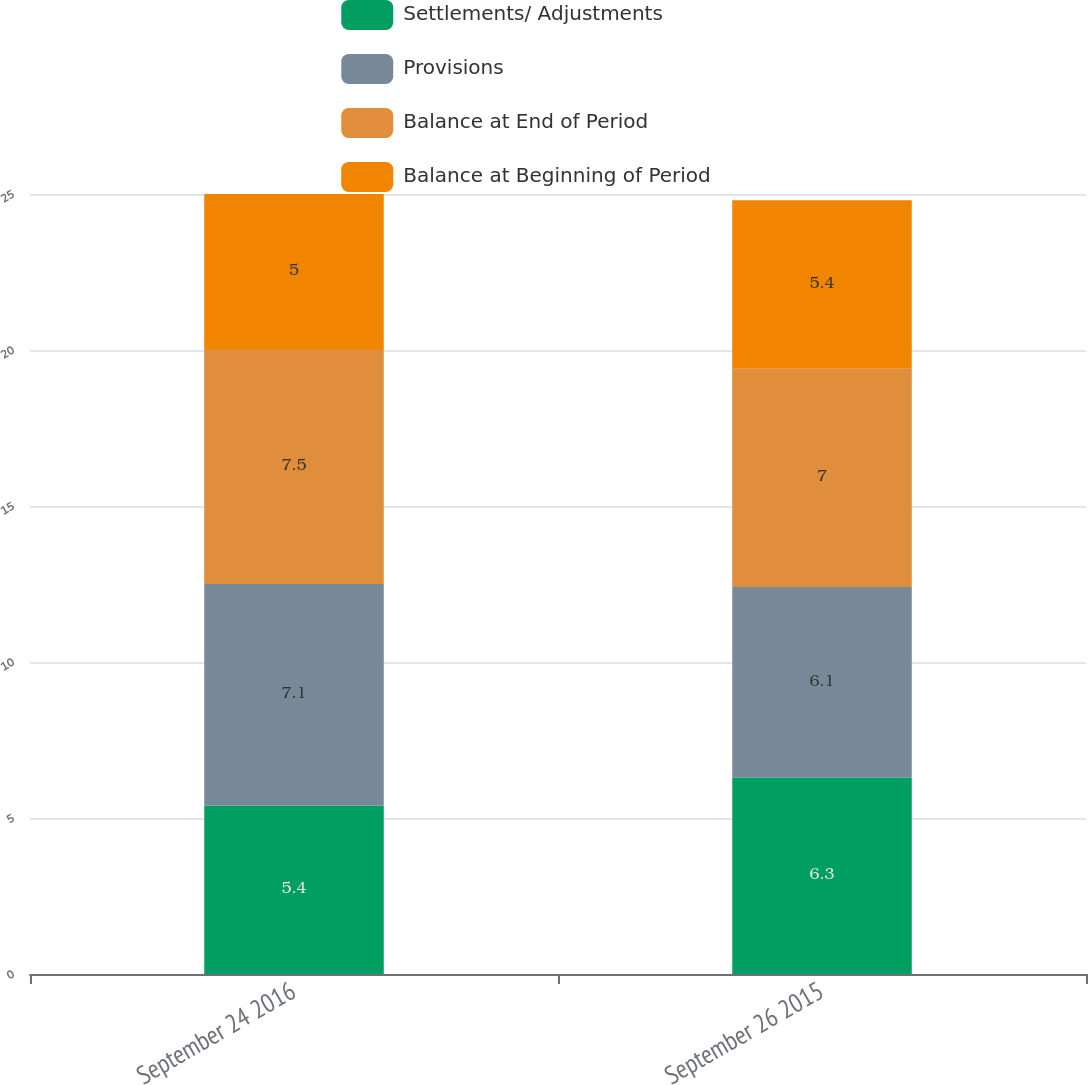<chart> <loc_0><loc_0><loc_500><loc_500><stacked_bar_chart><ecel><fcel>September 24 2016<fcel>September 26 2015<nl><fcel>Settlements/ Adjustments<fcel>5.4<fcel>6.3<nl><fcel>Provisions<fcel>7.1<fcel>6.1<nl><fcel>Balance at End of Period<fcel>7.5<fcel>7<nl><fcel>Balance at Beginning of Period<fcel>5<fcel>5.4<nl></chart> 